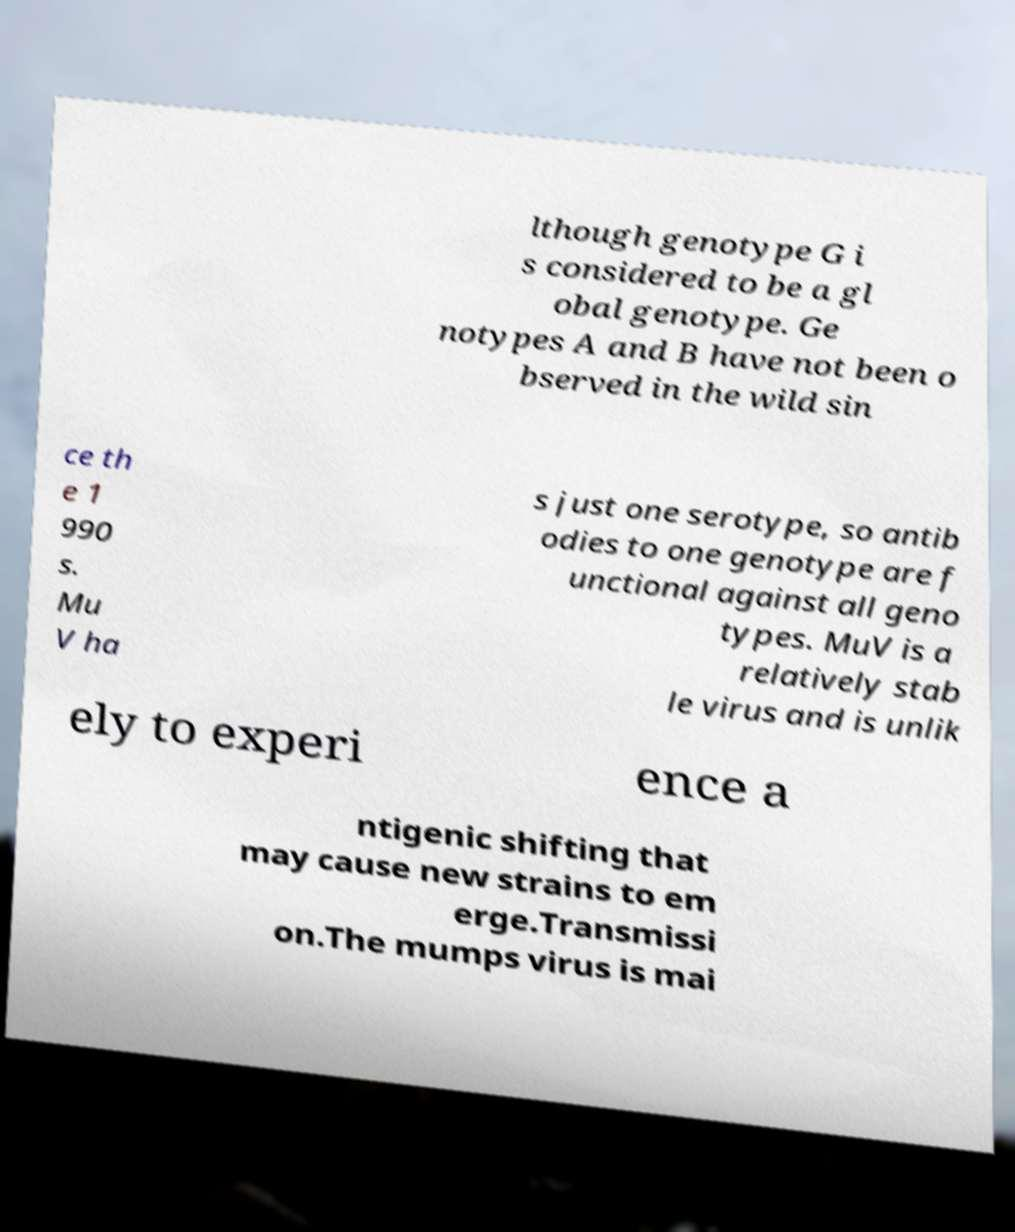Could you extract and type out the text from this image? lthough genotype G i s considered to be a gl obal genotype. Ge notypes A and B have not been o bserved in the wild sin ce th e 1 990 s. Mu V ha s just one serotype, so antib odies to one genotype are f unctional against all geno types. MuV is a relatively stab le virus and is unlik ely to experi ence a ntigenic shifting that may cause new strains to em erge.Transmissi on.The mumps virus is mai 